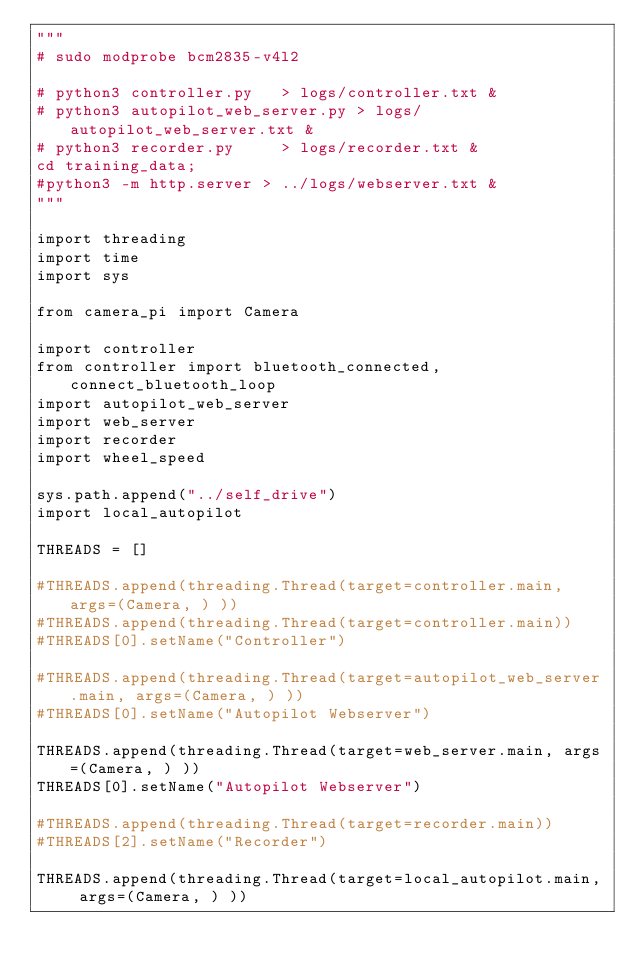<code> <loc_0><loc_0><loc_500><loc_500><_Python_>"""
# sudo modprobe bcm2835-v4l2

# python3 controller.py   > logs/controller.txt &
# python3 autopilot_web_server.py > logs/autopilot_web_server.txt &
# python3 recorder.py     > logs/recorder.txt &
cd training_data; 
#python3 -m http.server > ../logs/webserver.txt &
"""

import threading
import time
import sys

from camera_pi import Camera

import controller
from controller import bluetooth_connected, connect_bluetooth_loop
import autopilot_web_server
import web_server
import recorder
import wheel_speed

sys.path.append("../self_drive")
import local_autopilot

THREADS = []

#THREADS.append(threading.Thread(target=controller.main, args=(Camera, ) ))
#THREADS.append(threading.Thread(target=controller.main))
#THREADS[0].setName("Controller")

#THREADS.append(threading.Thread(target=autopilot_web_server.main, args=(Camera, ) ))
#THREADS[0].setName("Autopilot Webserver")

THREADS.append(threading.Thread(target=web_server.main, args=(Camera, ) ))
THREADS[0].setName("Autopilot Webserver")

#THREADS.append(threading.Thread(target=recorder.main))
#THREADS[2].setName("Recorder")

THREADS.append(threading.Thread(target=local_autopilot.main, args=(Camera, ) ))</code> 